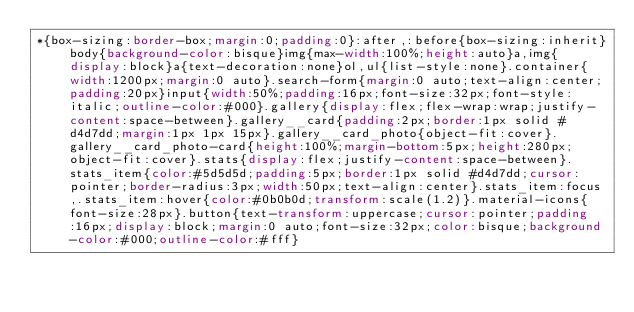Convert code to text. <code><loc_0><loc_0><loc_500><loc_500><_CSS_>*{box-sizing:border-box;margin:0;padding:0}:after,:before{box-sizing:inherit}body{background-color:bisque}img{max-width:100%;height:auto}a,img{display:block}a{text-decoration:none}ol,ul{list-style:none}.container{width:1200px;margin:0 auto}.search-form{margin:0 auto;text-align:center;padding:20px}input{width:50%;padding:16px;font-size:32px;font-style:italic;outline-color:#000}.gallery{display:flex;flex-wrap:wrap;justify-content:space-between}.gallery__card{padding:2px;border:1px solid #d4d7dd;margin:1px 1px 15px}.gallery__card_photo{object-fit:cover}.gallery__card_photo-card{height:100%;margin-bottom:5px;height:280px;object-fit:cover}.stats{display:flex;justify-content:space-between}.stats_item{color:#5d5d5d;padding:5px;border:1px solid #d4d7dd;cursor:pointer;border-radius:3px;width:50px;text-align:center}.stats_item:focus,.stats_item:hover{color:#0b0b0d;transform:scale(1.2)}.material-icons{font-size:28px}.button{text-transform:uppercase;cursor:pointer;padding:16px;display:block;margin:0 auto;font-size:32px;color:bisque;background-color:#000;outline-color:#fff}</code> 